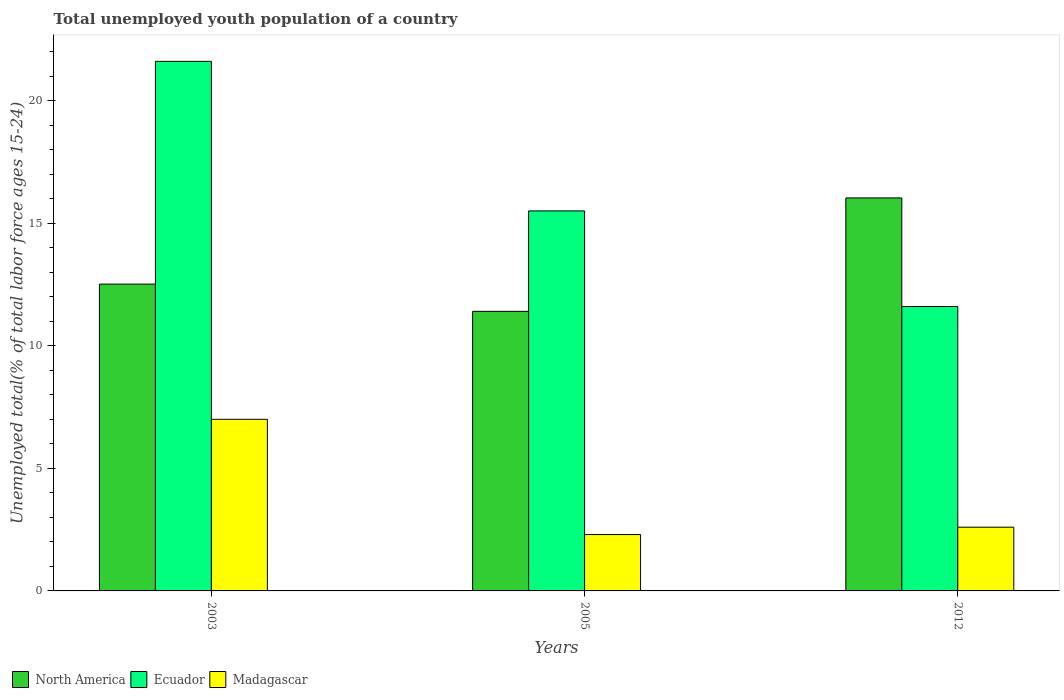How many different coloured bars are there?
Your response must be concise. 3. Are the number of bars per tick equal to the number of legend labels?
Give a very brief answer. Yes. Are the number of bars on each tick of the X-axis equal?
Give a very brief answer. Yes. How many bars are there on the 2nd tick from the right?
Give a very brief answer. 3. What is the percentage of total unemployed youth population of a country in North America in 2005?
Ensure brevity in your answer.  11.4. Across all years, what is the minimum percentage of total unemployed youth population of a country in Madagascar?
Your answer should be compact. 2.3. In which year was the percentage of total unemployed youth population of a country in Madagascar minimum?
Provide a succinct answer. 2005. What is the total percentage of total unemployed youth population of a country in North America in the graph?
Your response must be concise. 39.95. What is the difference between the percentage of total unemployed youth population of a country in Ecuador in 2005 and that in 2012?
Your answer should be compact. 3.9. What is the difference between the percentage of total unemployed youth population of a country in Madagascar in 2005 and the percentage of total unemployed youth population of a country in Ecuador in 2003?
Give a very brief answer. -19.3. What is the average percentage of total unemployed youth population of a country in Ecuador per year?
Offer a very short reply. 16.23. In the year 2012, what is the difference between the percentage of total unemployed youth population of a country in North America and percentage of total unemployed youth population of a country in Madagascar?
Keep it short and to the point. 13.43. In how many years, is the percentage of total unemployed youth population of a country in North America greater than 3 %?
Ensure brevity in your answer.  3. What is the ratio of the percentage of total unemployed youth population of a country in Ecuador in 2003 to that in 2012?
Provide a short and direct response. 1.86. Is the difference between the percentage of total unemployed youth population of a country in North America in 2003 and 2005 greater than the difference between the percentage of total unemployed youth population of a country in Madagascar in 2003 and 2005?
Your response must be concise. No. What is the difference between the highest and the second highest percentage of total unemployed youth population of a country in North America?
Ensure brevity in your answer.  3.52. What is the difference between the highest and the lowest percentage of total unemployed youth population of a country in Madagascar?
Your response must be concise. 4.7. In how many years, is the percentage of total unemployed youth population of a country in Madagascar greater than the average percentage of total unemployed youth population of a country in Madagascar taken over all years?
Give a very brief answer. 1. What does the 1st bar from the left in 2012 represents?
Your answer should be compact. North America. What does the 3rd bar from the right in 2012 represents?
Your answer should be very brief. North America. Is it the case that in every year, the sum of the percentage of total unemployed youth population of a country in Ecuador and percentage of total unemployed youth population of a country in Madagascar is greater than the percentage of total unemployed youth population of a country in North America?
Offer a very short reply. No. How many bars are there?
Your response must be concise. 9. Does the graph contain grids?
Your answer should be very brief. No. How are the legend labels stacked?
Keep it short and to the point. Horizontal. What is the title of the graph?
Your answer should be compact. Total unemployed youth population of a country. What is the label or title of the X-axis?
Provide a succinct answer. Years. What is the label or title of the Y-axis?
Offer a terse response. Unemployed total(% of total labor force ages 15-24). What is the Unemployed total(% of total labor force ages 15-24) in North America in 2003?
Offer a very short reply. 12.51. What is the Unemployed total(% of total labor force ages 15-24) in Ecuador in 2003?
Your answer should be very brief. 21.6. What is the Unemployed total(% of total labor force ages 15-24) in North America in 2005?
Keep it short and to the point. 11.4. What is the Unemployed total(% of total labor force ages 15-24) of Madagascar in 2005?
Ensure brevity in your answer.  2.3. What is the Unemployed total(% of total labor force ages 15-24) of North America in 2012?
Give a very brief answer. 16.03. What is the Unemployed total(% of total labor force ages 15-24) in Ecuador in 2012?
Your answer should be compact. 11.6. What is the Unemployed total(% of total labor force ages 15-24) in Madagascar in 2012?
Provide a short and direct response. 2.6. Across all years, what is the maximum Unemployed total(% of total labor force ages 15-24) in North America?
Make the answer very short. 16.03. Across all years, what is the maximum Unemployed total(% of total labor force ages 15-24) in Ecuador?
Offer a terse response. 21.6. Across all years, what is the minimum Unemployed total(% of total labor force ages 15-24) of North America?
Your answer should be compact. 11.4. Across all years, what is the minimum Unemployed total(% of total labor force ages 15-24) in Ecuador?
Your answer should be compact. 11.6. Across all years, what is the minimum Unemployed total(% of total labor force ages 15-24) of Madagascar?
Give a very brief answer. 2.3. What is the total Unemployed total(% of total labor force ages 15-24) in North America in the graph?
Your response must be concise. 39.95. What is the total Unemployed total(% of total labor force ages 15-24) in Ecuador in the graph?
Give a very brief answer. 48.7. What is the difference between the Unemployed total(% of total labor force ages 15-24) in North America in 2003 and that in 2005?
Offer a very short reply. 1.11. What is the difference between the Unemployed total(% of total labor force ages 15-24) of Madagascar in 2003 and that in 2005?
Give a very brief answer. 4.7. What is the difference between the Unemployed total(% of total labor force ages 15-24) in North America in 2003 and that in 2012?
Offer a terse response. -3.52. What is the difference between the Unemployed total(% of total labor force ages 15-24) of Madagascar in 2003 and that in 2012?
Your answer should be very brief. 4.4. What is the difference between the Unemployed total(% of total labor force ages 15-24) in North America in 2005 and that in 2012?
Offer a very short reply. -4.63. What is the difference between the Unemployed total(% of total labor force ages 15-24) in Madagascar in 2005 and that in 2012?
Offer a terse response. -0.3. What is the difference between the Unemployed total(% of total labor force ages 15-24) of North America in 2003 and the Unemployed total(% of total labor force ages 15-24) of Ecuador in 2005?
Keep it short and to the point. -2.99. What is the difference between the Unemployed total(% of total labor force ages 15-24) of North America in 2003 and the Unemployed total(% of total labor force ages 15-24) of Madagascar in 2005?
Make the answer very short. 10.21. What is the difference between the Unemployed total(% of total labor force ages 15-24) in Ecuador in 2003 and the Unemployed total(% of total labor force ages 15-24) in Madagascar in 2005?
Keep it short and to the point. 19.3. What is the difference between the Unemployed total(% of total labor force ages 15-24) in North America in 2003 and the Unemployed total(% of total labor force ages 15-24) in Ecuador in 2012?
Offer a very short reply. 0.91. What is the difference between the Unemployed total(% of total labor force ages 15-24) in North America in 2003 and the Unemployed total(% of total labor force ages 15-24) in Madagascar in 2012?
Ensure brevity in your answer.  9.91. What is the difference between the Unemployed total(% of total labor force ages 15-24) in Ecuador in 2003 and the Unemployed total(% of total labor force ages 15-24) in Madagascar in 2012?
Your answer should be very brief. 19. What is the difference between the Unemployed total(% of total labor force ages 15-24) of North America in 2005 and the Unemployed total(% of total labor force ages 15-24) of Ecuador in 2012?
Offer a terse response. -0.2. What is the difference between the Unemployed total(% of total labor force ages 15-24) of North America in 2005 and the Unemployed total(% of total labor force ages 15-24) of Madagascar in 2012?
Your response must be concise. 8.8. What is the difference between the Unemployed total(% of total labor force ages 15-24) of Ecuador in 2005 and the Unemployed total(% of total labor force ages 15-24) of Madagascar in 2012?
Offer a very short reply. 12.9. What is the average Unemployed total(% of total labor force ages 15-24) in North America per year?
Your answer should be compact. 13.32. What is the average Unemployed total(% of total labor force ages 15-24) in Ecuador per year?
Your answer should be compact. 16.23. What is the average Unemployed total(% of total labor force ages 15-24) of Madagascar per year?
Make the answer very short. 3.97. In the year 2003, what is the difference between the Unemployed total(% of total labor force ages 15-24) in North America and Unemployed total(% of total labor force ages 15-24) in Ecuador?
Provide a short and direct response. -9.09. In the year 2003, what is the difference between the Unemployed total(% of total labor force ages 15-24) in North America and Unemployed total(% of total labor force ages 15-24) in Madagascar?
Your answer should be compact. 5.51. In the year 2005, what is the difference between the Unemployed total(% of total labor force ages 15-24) of North America and Unemployed total(% of total labor force ages 15-24) of Ecuador?
Your response must be concise. -4.1. In the year 2005, what is the difference between the Unemployed total(% of total labor force ages 15-24) of North America and Unemployed total(% of total labor force ages 15-24) of Madagascar?
Keep it short and to the point. 9.1. In the year 2012, what is the difference between the Unemployed total(% of total labor force ages 15-24) in North America and Unemployed total(% of total labor force ages 15-24) in Ecuador?
Provide a short and direct response. 4.43. In the year 2012, what is the difference between the Unemployed total(% of total labor force ages 15-24) in North America and Unemployed total(% of total labor force ages 15-24) in Madagascar?
Provide a succinct answer. 13.43. What is the ratio of the Unemployed total(% of total labor force ages 15-24) in North America in 2003 to that in 2005?
Ensure brevity in your answer.  1.1. What is the ratio of the Unemployed total(% of total labor force ages 15-24) in Ecuador in 2003 to that in 2005?
Your answer should be compact. 1.39. What is the ratio of the Unemployed total(% of total labor force ages 15-24) of Madagascar in 2003 to that in 2005?
Provide a short and direct response. 3.04. What is the ratio of the Unemployed total(% of total labor force ages 15-24) of North America in 2003 to that in 2012?
Provide a short and direct response. 0.78. What is the ratio of the Unemployed total(% of total labor force ages 15-24) of Ecuador in 2003 to that in 2012?
Keep it short and to the point. 1.86. What is the ratio of the Unemployed total(% of total labor force ages 15-24) in Madagascar in 2003 to that in 2012?
Offer a terse response. 2.69. What is the ratio of the Unemployed total(% of total labor force ages 15-24) of North America in 2005 to that in 2012?
Your response must be concise. 0.71. What is the ratio of the Unemployed total(% of total labor force ages 15-24) of Ecuador in 2005 to that in 2012?
Give a very brief answer. 1.34. What is the ratio of the Unemployed total(% of total labor force ages 15-24) of Madagascar in 2005 to that in 2012?
Offer a very short reply. 0.88. What is the difference between the highest and the second highest Unemployed total(% of total labor force ages 15-24) of North America?
Your response must be concise. 3.52. What is the difference between the highest and the second highest Unemployed total(% of total labor force ages 15-24) of Ecuador?
Your response must be concise. 6.1. What is the difference between the highest and the lowest Unemployed total(% of total labor force ages 15-24) of North America?
Your response must be concise. 4.63. 